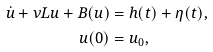<formula> <loc_0><loc_0><loc_500><loc_500>\dot { u } + \nu L u + B ( u ) & = h ( t ) + \eta ( t ) , \\ u ( 0 ) & = u _ { 0 } ,</formula> 